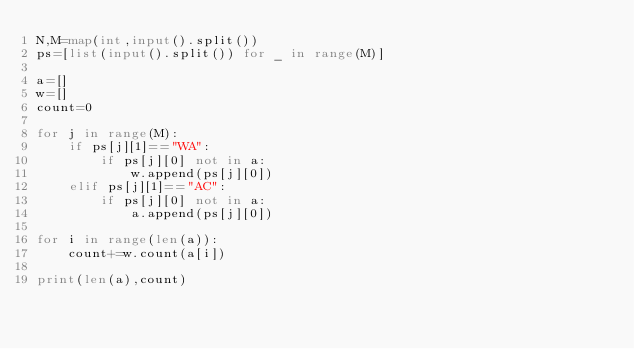Convert code to text. <code><loc_0><loc_0><loc_500><loc_500><_Python_>N,M=map(int,input().split())
ps=[list(input().split()) for _ in range(M)]

a=[]
w=[]
count=0

for j in range(M):
    if ps[j][1]=="WA":
        if ps[j][0] not in a:
            w.append(ps[j][0])
    elif ps[j][1]=="AC":
        if ps[j][0] not in a:
            a.append(ps[j][0])

for i in range(len(a)):
    count+=w.count(a[i])

print(len(a),count)</code> 